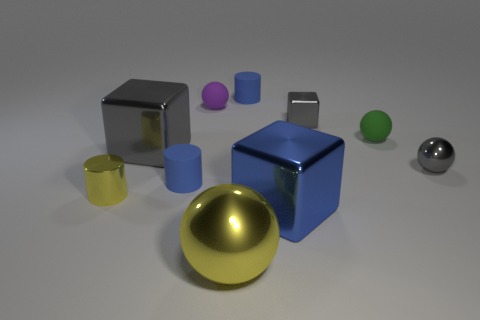What is the blue object right of the small blue cylinder to the right of the big yellow metal ball made of?
Your response must be concise. Metal. Are there any brown balls?
Provide a succinct answer. No. There is a blue metal object that is in front of the big block that is to the left of the purple matte ball; how big is it?
Provide a succinct answer. Large. Is the number of tiny blue matte things in front of the tiny purple matte ball greater than the number of large yellow metal things to the right of the big yellow metallic object?
Give a very brief answer. Yes. How many cubes are blue metallic objects or small gray things?
Ensure brevity in your answer.  2. Are there any other things that are the same size as the green matte ball?
Make the answer very short. Yes. There is a big thing on the left side of the yellow metallic sphere; does it have the same shape as the big blue metallic object?
Your answer should be very brief. Yes. The large sphere has what color?
Your answer should be very brief. Yellow. What color is the other metallic object that is the same shape as the large yellow thing?
Offer a terse response. Gray. What number of other objects have the same shape as the big gray shiny thing?
Keep it short and to the point. 2. 